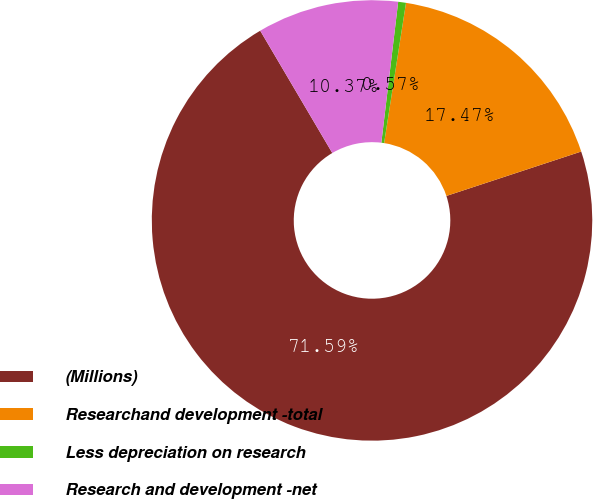Convert chart. <chart><loc_0><loc_0><loc_500><loc_500><pie_chart><fcel>(Millions)<fcel>Researchand development -total<fcel>Less depreciation on research<fcel>Research and development -net<nl><fcel>71.59%<fcel>17.47%<fcel>0.57%<fcel>10.37%<nl></chart> 